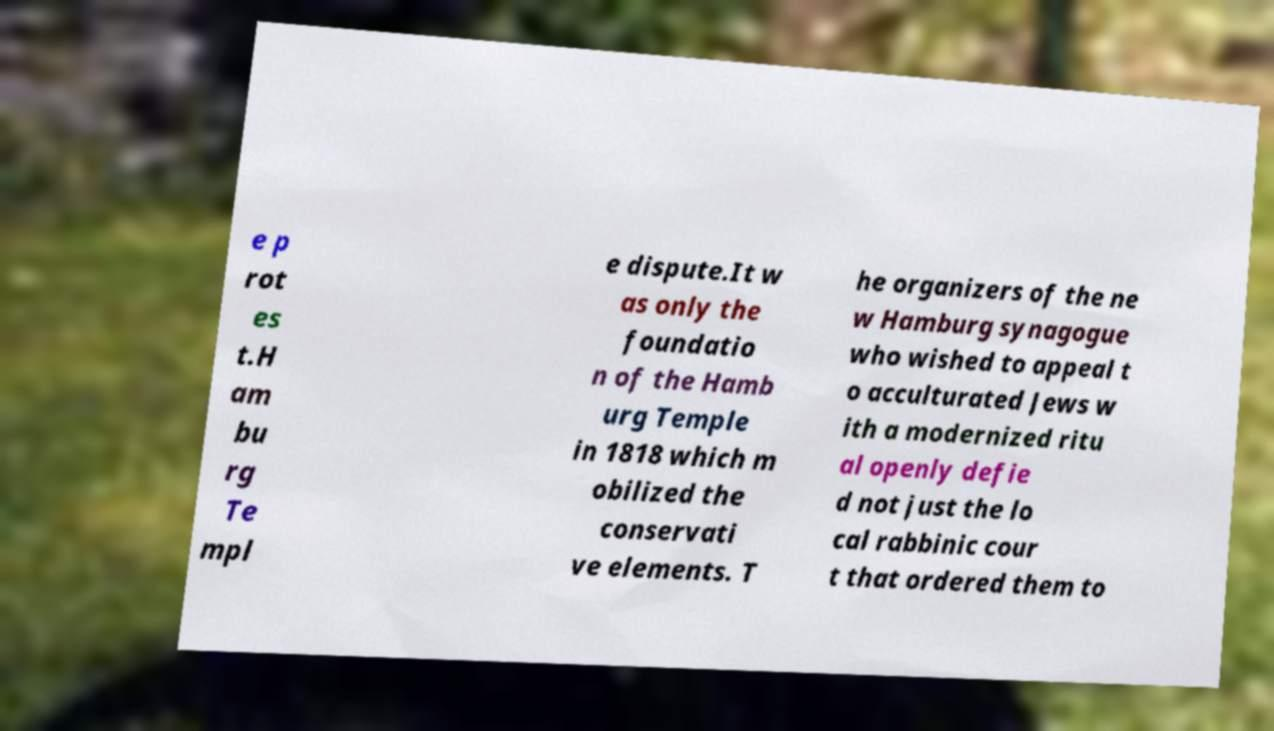Can you read and provide the text displayed in the image?This photo seems to have some interesting text. Can you extract and type it out for me? e p rot es t.H am bu rg Te mpl e dispute.It w as only the foundatio n of the Hamb urg Temple in 1818 which m obilized the conservati ve elements. T he organizers of the ne w Hamburg synagogue who wished to appeal t o acculturated Jews w ith a modernized ritu al openly defie d not just the lo cal rabbinic cour t that ordered them to 